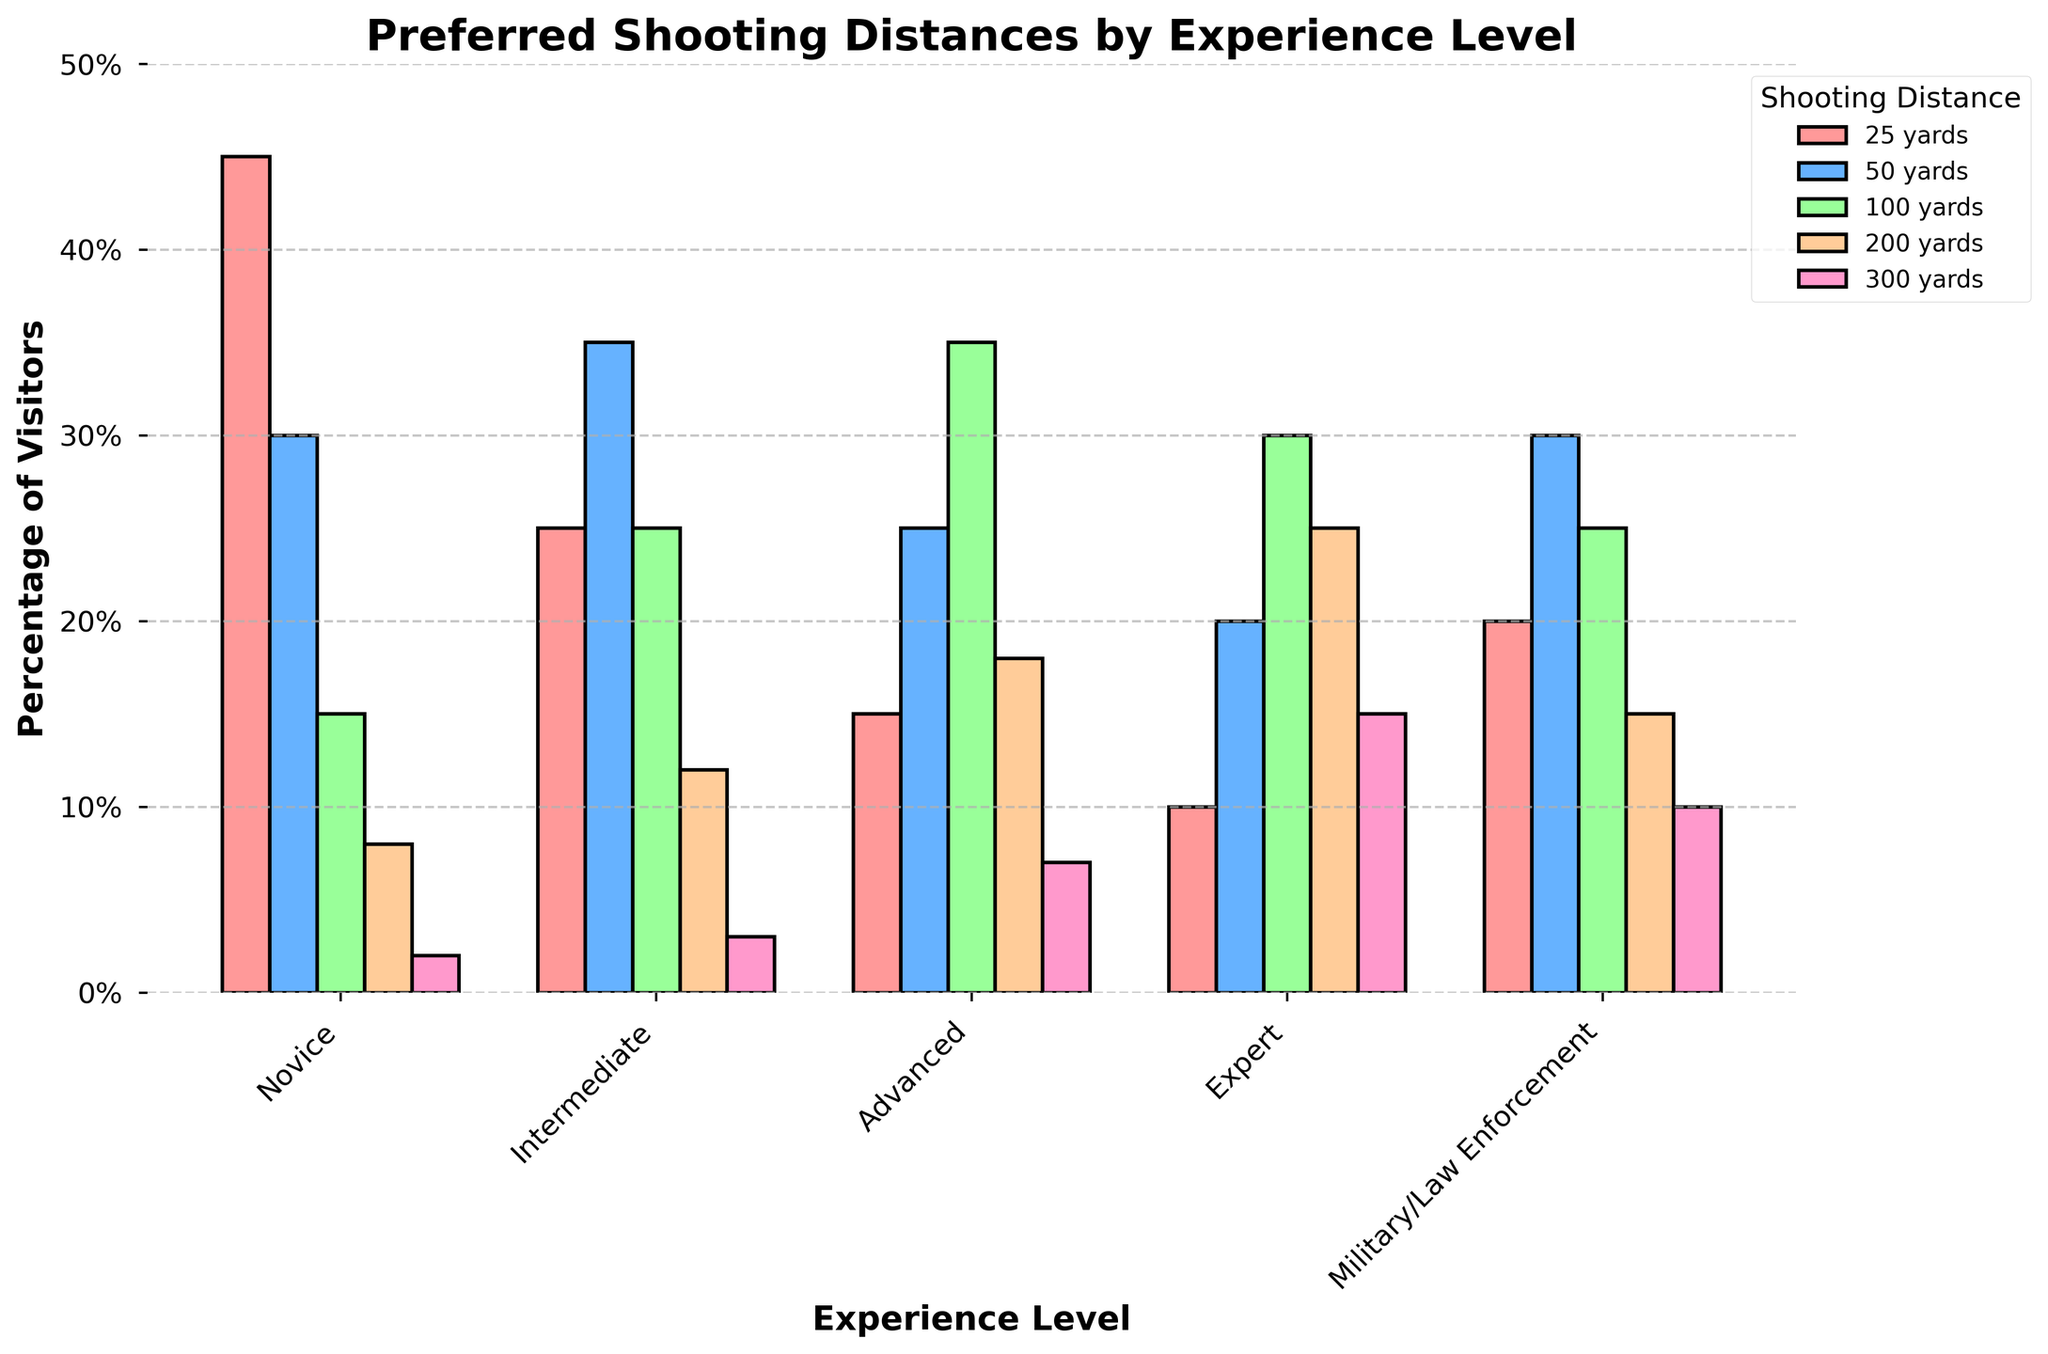What's the most popular shooting distance among novices? To find the most popular shooting distance for novices, observe the chart for the highest percentage bar in the Novice category. The tallest bar corresponds to 25 yards with 45%.
Answer: 25 yards Which experience level has the highest preference for 300 yards? Look for the tallest bar under the 300 yards category across all experience levels. The highest bar for 300 yards is in the Expert category, which is 15%.
Answer: Expert Does any experience level prefer 50 yards more than 25 yards? Compare the heights of the bars for 25 yards and 50 yards within each experience level. The Intermediate group prefers 50 yards (35%) over 25 yards (25%).
Answer: Intermediate Which shooting distance does the Advanced level favor over all other distances? Find the tallest bar in the Advanced category. The tallest bar corresponds to 100 yards with 35%.
Answer: 100 yards What is the total combined preference percentage for 200 yards and 300 yards among experts? Sum the percentages for 200 yards (25%) and 300 yards (15%) in the Expert category. The combined total is 25% + 15% = 40%.
Answer: 40% Compare the preference for 100 yards between Intermediate and Advanced levels. Which one is higher and by how much? Check the bars for 100 yards in both Intermediate (25%) and Advanced (35%) categories. The Advanced level prefers 100 yards by 35% - 25% = 10% more than the Intermediate level.
Answer: Advanced, 10% Which shooting distance is least preferred by Novices? Identify the shortest bar in the Novice category. The shortest bar represents 300 yards, preferred by only 2%.
Answer: 300 yards What is the average preference for 25 yards across all experience levels? Add the percentages of preference for 25 yards across all groups (Novice: 45%, Intermediate: 25%, Advanced: 15%, Expert: 10%, Military/Law Enforcement: 20%) and divide by 5. The sum is 115%, and the average is 115% / 5 = 23%.
Answer: 23% Which two experience levels have an equal percentage preference for any shooting distance? Look for any bars of the same height for any shooting distance across all experience levels. Both Advanced and Military/Law Enforcement have a 25% preference for 100 yards.
Answer: Advanced and Military/Law Enforcement 